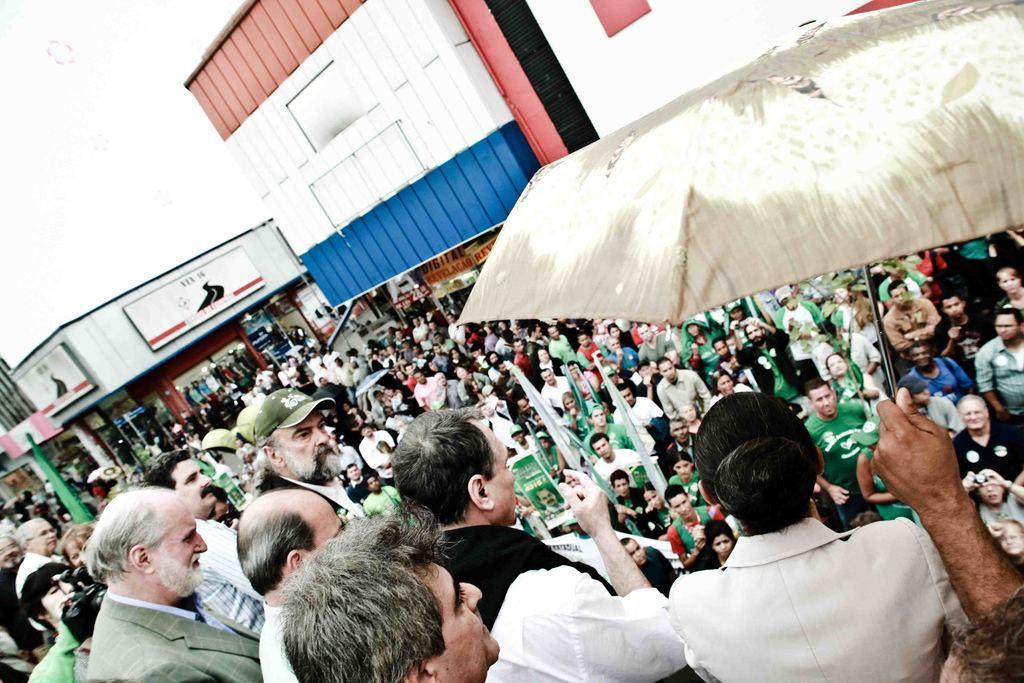How would you summarize this image in a sentence or two? In the picture I can see few persons standing and there is a hand of a hand of a person holding an umbrella in his hands and there are few people standing in front of them and there are few buildings in the background. 